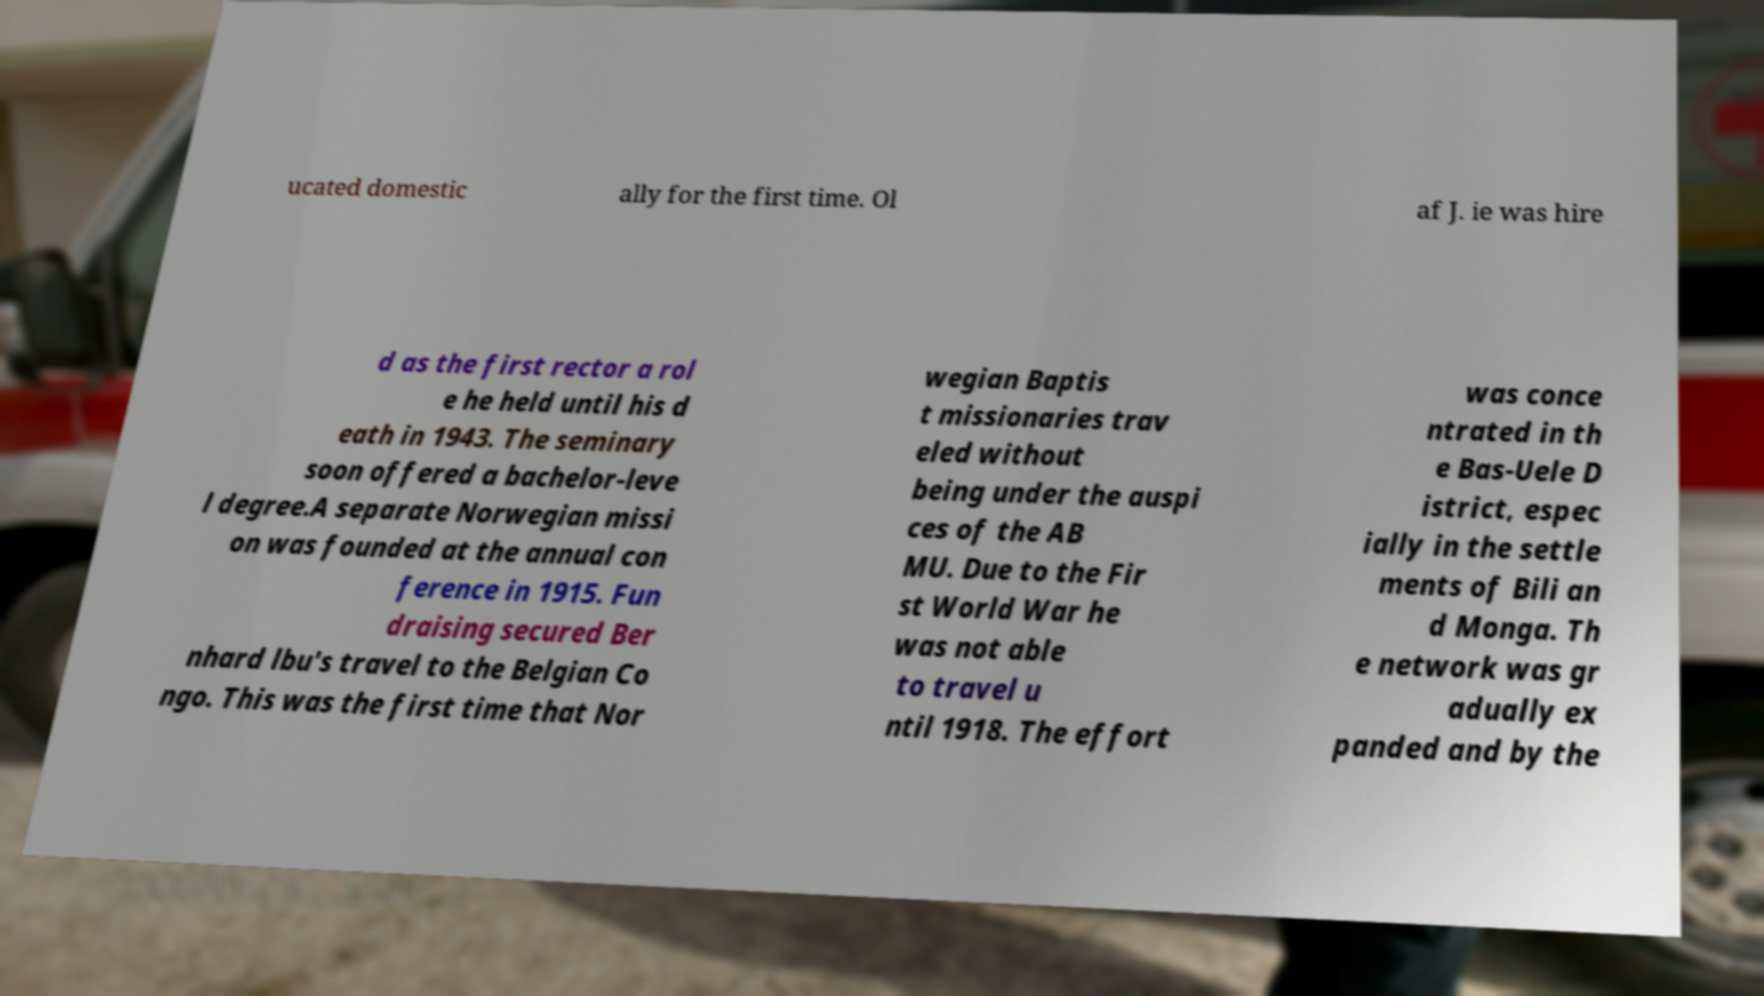What messages or text are displayed in this image? I need them in a readable, typed format. ucated domestic ally for the first time. Ol af J. ie was hire d as the first rector a rol e he held until his d eath in 1943. The seminary soon offered a bachelor-leve l degree.A separate Norwegian missi on was founded at the annual con ference in 1915. Fun draising secured Ber nhard lbu's travel to the Belgian Co ngo. This was the first time that Nor wegian Baptis t missionaries trav eled without being under the auspi ces of the AB MU. Due to the Fir st World War he was not able to travel u ntil 1918. The effort was conce ntrated in th e Bas-Uele D istrict, espec ially in the settle ments of Bili an d Monga. Th e network was gr adually ex panded and by the 